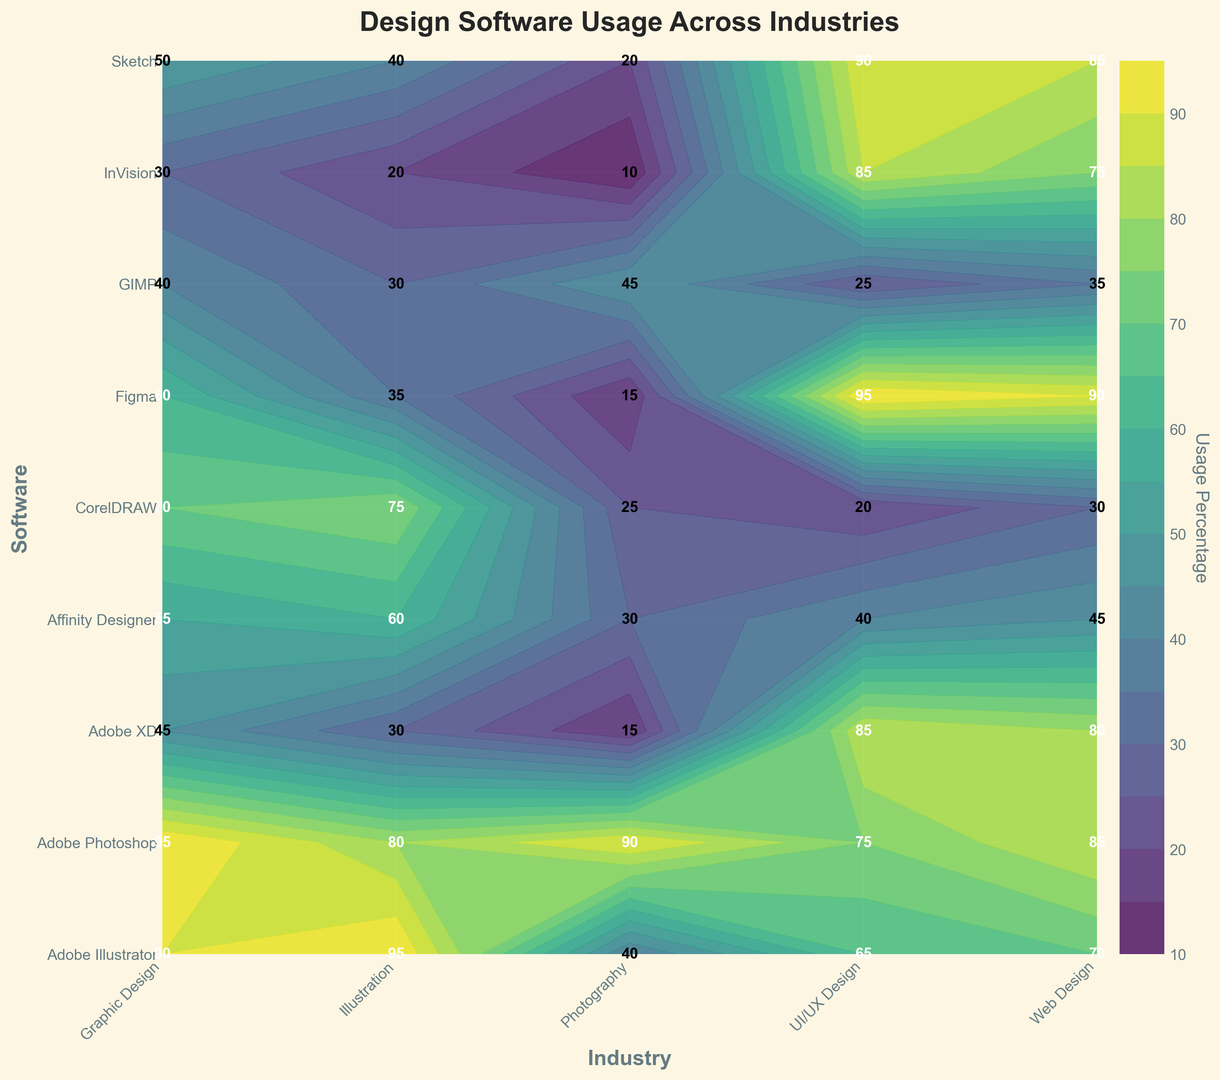Which software is the most popular among Web Designers? The most popular software is identified by the highest usage percentage among Web Designers. From the plot, we can see that Figma has a usage percentage of 90, which is the highest in the Web Design industry.
Answer: Figma What is the least used software in Photography? The least used software is the one with the lowest usage percentage in the Photography category. By examining the plot, we see that InVision has the lowest percentage with a value of 10.
Answer: InVision How does the usage of Adobe Photoshop in UI/UX Design compare to its usage in Graphic Design? Compare the usage percentages of Adobe Photoshop in both UI/UX Design and Graphic Design. Adobe Photoshop has a usage percentage of 75 in UI/UX Design and 95 in Graphic Design, indicating it is more popular in Graphic Design.
Answer: More popular in Graphic Design What is the average usage percentage of CorelDRAW across all industries? Calculate the average of the usage percentages for CorelDRAW across all listed industries: (70 + 30 + 25 + 75 + 20) / 5 = 44.
Answer: 44 Which industry has the highest usage for Sketch, and what is the percentage? Identify the industry with the highest usage percentage for Sketch by comparing all the usage values associated with Sketch. Sketch has a usage of 90 in UI/UX Design, which is the highest.
Answer: UI/UX Design, 90 How does the usage of Figma in UI/UX Design compare to the usage of Sketch in the same industry? Compare the usage percentages of both Figma and Sketch within the UI/UX Design industry. Figma has a usage percentage of 95, while Sketch has a usage percentage of 90 in UI/UX Design.
Answer: Figma has higher usage What is the total usage percentage for InVision across Graphic Design and Web Design industries? The total usage percentage is the sum of usage for InVision in Graphic Design and Web Design. This is 30 for Graphic Design plus 75 for Web Design, resulting in a total of 105.
Answer: 105 Which software has the most balanced usage across all industries, and what is its average usage percentage? To find the most balanced software, compare the usage variations and determine the software with minimal differences across industries. Then calculate the average usage percentage. Adobe Photoshop is quite balanced with an average usage across all industries of (95+85+90+80+75) / 5 = 85.
Answer: Adobe Photoshop, 85 Compare the usage of GIMP and Affinity Designer in the Illustration industry. Which one is more popular? Look at the usage percentages of both GIMP and Affinity Designer in the Illustration industry. GIMP has a usage of 30, while Affinity Designer has a usage of 60. Therefore, Affinity Designer is more popular.
Answer: Affinity Designer What is the difference between the highest and lowest usage percentages for Adobe XD in all industries? Identify the highest and lowest usage percentages for Adobe XD from the plot and calculate the difference. The highest is 85 (in both Web Design and UI/UX Design), and the lowest is 15 (in Photography). The difference is 85 - 15 = 70.
Answer: 70 